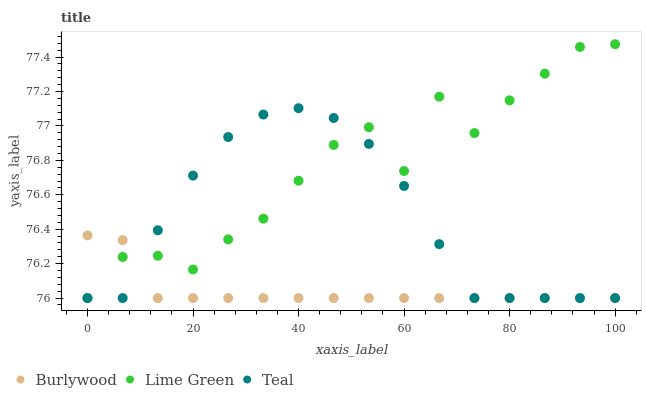Does Burlywood have the minimum area under the curve?
Answer yes or no. Yes. Does Lime Green have the maximum area under the curve?
Answer yes or no. Yes. Does Teal have the minimum area under the curve?
Answer yes or no. No. Does Teal have the maximum area under the curve?
Answer yes or no. No. Is Burlywood the smoothest?
Answer yes or no. Yes. Is Lime Green the roughest?
Answer yes or no. Yes. Is Teal the smoothest?
Answer yes or no. No. Is Teal the roughest?
Answer yes or no. No. Does Burlywood have the lowest value?
Answer yes or no. Yes. Does Lime Green have the highest value?
Answer yes or no. Yes. Does Teal have the highest value?
Answer yes or no. No. Does Lime Green intersect Burlywood?
Answer yes or no. Yes. Is Lime Green less than Burlywood?
Answer yes or no. No. Is Lime Green greater than Burlywood?
Answer yes or no. No. 